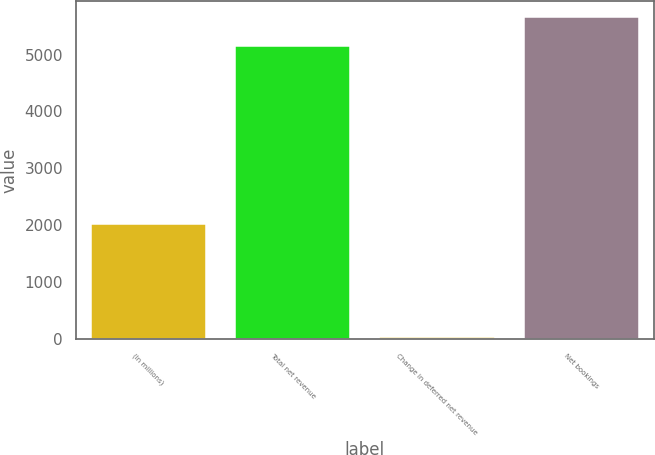<chart> <loc_0><loc_0><loc_500><loc_500><bar_chart><fcel>(In millions)<fcel>Total net revenue<fcel>Change in deferred net revenue<fcel>Net bookings<nl><fcel>2018<fcel>5150<fcel>30<fcel>5665<nl></chart> 